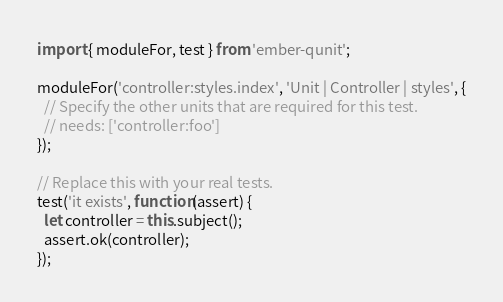Convert code to text. <code><loc_0><loc_0><loc_500><loc_500><_JavaScript_>import { moduleFor, test } from 'ember-qunit';

moduleFor('controller:styles.index', 'Unit | Controller | styles', {
  // Specify the other units that are required for this test.
  // needs: ['controller:foo']
});

// Replace this with your real tests.
test('it exists', function(assert) {
  let controller = this.subject();
  assert.ok(controller);
});
</code> 